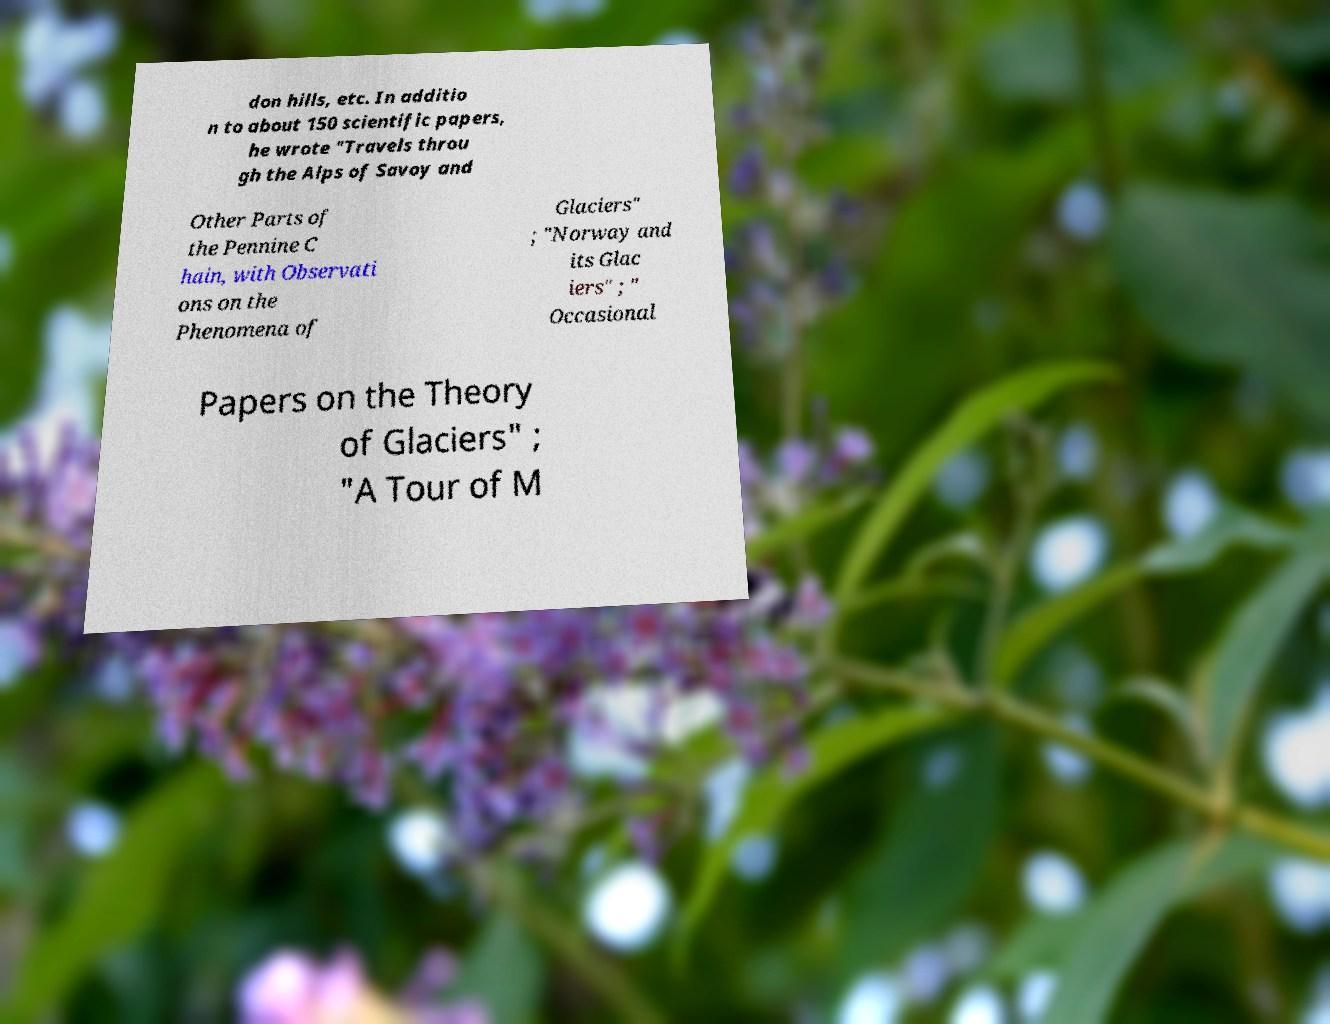There's text embedded in this image that I need extracted. Can you transcribe it verbatim? don hills, etc. In additio n to about 150 scientific papers, he wrote "Travels throu gh the Alps of Savoy and Other Parts of the Pennine C hain, with Observati ons on the Phenomena of Glaciers" ; "Norway and its Glac iers" ; " Occasional Papers on the Theory of Glaciers" ; "A Tour of M 